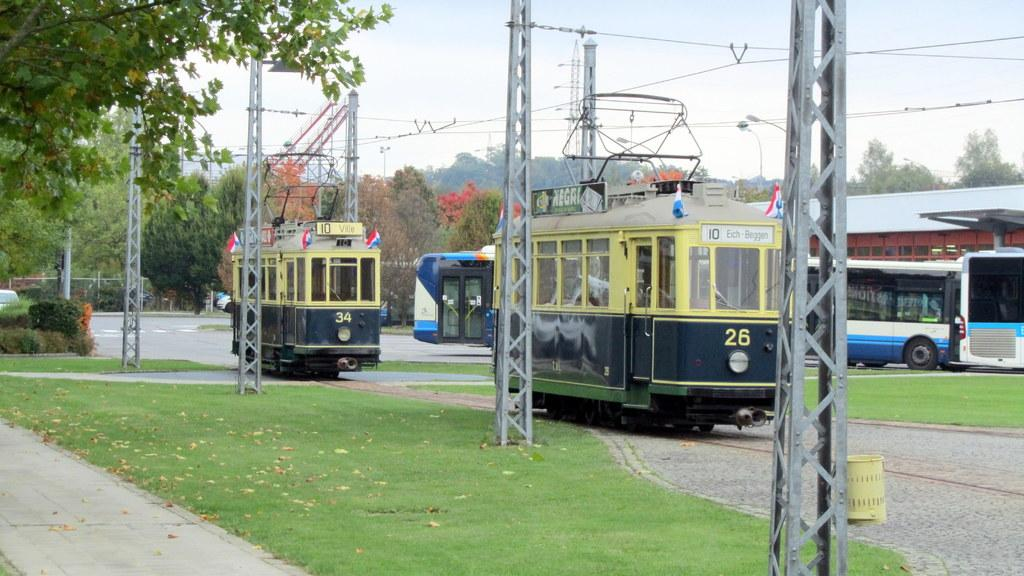What type of vehicles can be seen in the image? There are trains in the image. What structures are present in the image? Electric poles, street lights, and iron grills can be seen in the image. What type of vegetation is in the image? There are trees in the image. What is visible on the ground in the image? Shredded leaves are visible on the ground in the image. What part of the natural environment is visible in the image? The sky is visible in the image. Reasoning: Let' Let's think step by step in order to produce the conversation. We start by identifying the main subjects and objects in the image based on the provided facts. We then formulate questions that focus on the location and characteristics of these subjects and objects, ensuring that each question can be answered definitively with the information given. We avoid yes/no questions and ensure that the language is simple and clear. Absurd Question/Answer: What type of writing can be seen on the brick wall in the image? There is no brick wall present in the image, so no writing can be observed. What is the color of the neck of the person in the image? There is no person present in the image, so their neck color cannot be determined. 